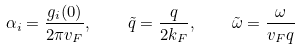<formula> <loc_0><loc_0><loc_500><loc_500>\alpha _ { i } = \frac { g _ { i } ( 0 ) } { 2 \pi v _ { F } } , \quad \tilde { q } = \frac { q } { 2 k _ { F } } , \quad \tilde { \omega } = \frac { \omega } { v _ { F } q }</formula> 